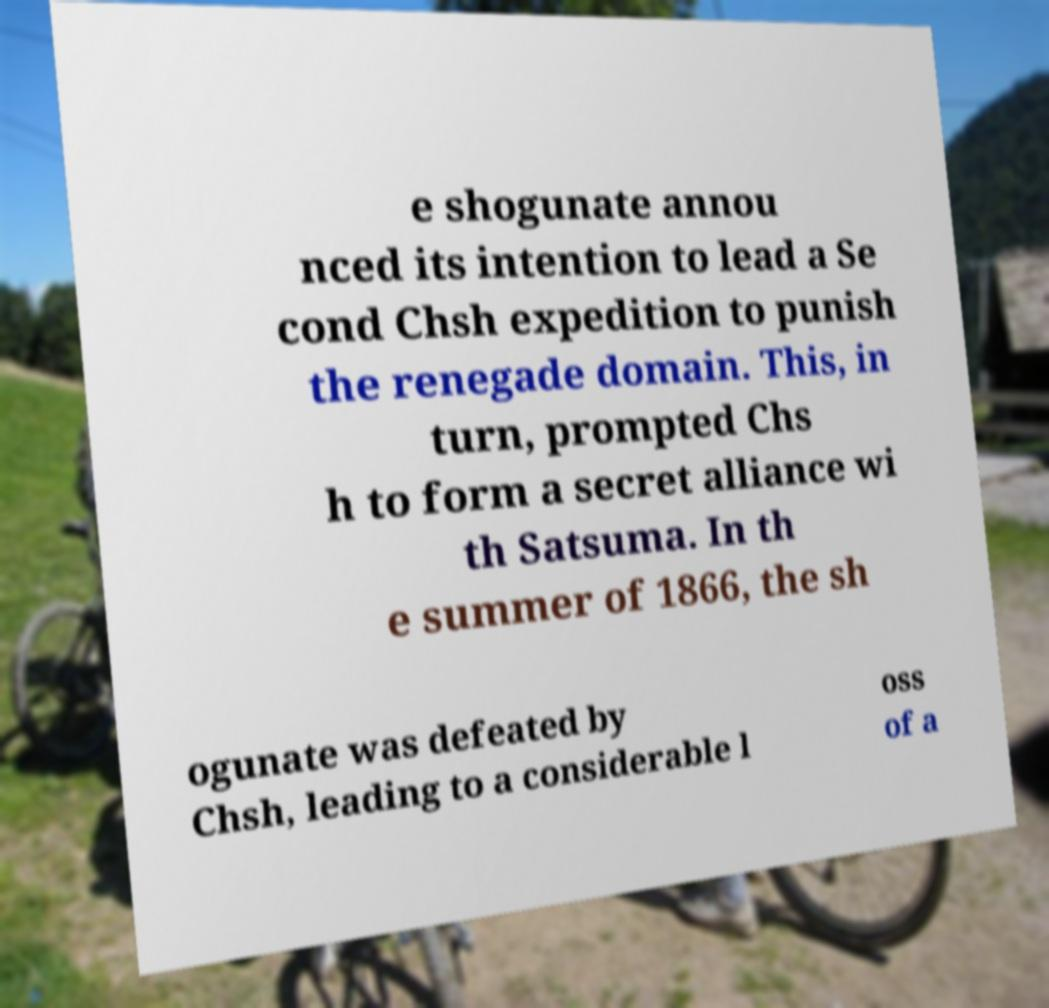For documentation purposes, I need the text within this image transcribed. Could you provide that? e shogunate annou nced its intention to lead a Se cond Chsh expedition to punish the renegade domain. This, in turn, prompted Chs h to form a secret alliance wi th Satsuma. In th e summer of 1866, the sh ogunate was defeated by Chsh, leading to a considerable l oss of a 